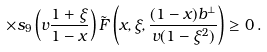<formula> <loc_0><loc_0><loc_500><loc_500>\times s _ { 9 } \left ( v \frac { 1 + \xi } { 1 - x } \right ) \tilde { F } \left ( x , \xi , \frac { ( 1 - x ) b ^ { \perp } } { v ( 1 - \xi ^ { 2 } ) } \right ) \geq 0 \, .</formula> 